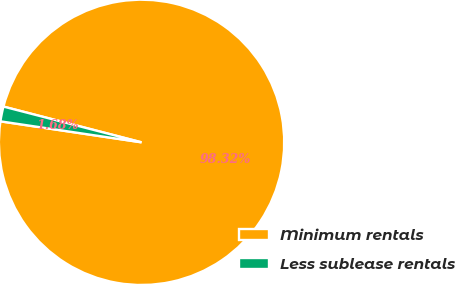<chart> <loc_0><loc_0><loc_500><loc_500><pie_chart><fcel>Minimum rentals<fcel>Less sublease rentals<nl><fcel>98.32%<fcel>1.68%<nl></chart> 